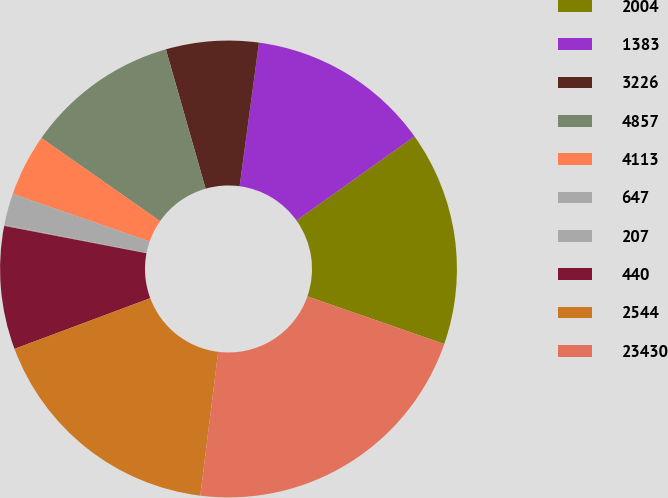Convert chart to OTSL. <chart><loc_0><loc_0><loc_500><loc_500><pie_chart><fcel>2004<fcel>1383<fcel>3226<fcel>4857<fcel>4113<fcel>647<fcel>207<fcel>440<fcel>2544<fcel>23430<nl><fcel>15.18%<fcel>13.02%<fcel>6.55%<fcel>10.86%<fcel>4.39%<fcel>2.23%<fcel>0.08%<fcel>8.71%<fcel>17.34%<fcel>21.65%<nl></chart> 